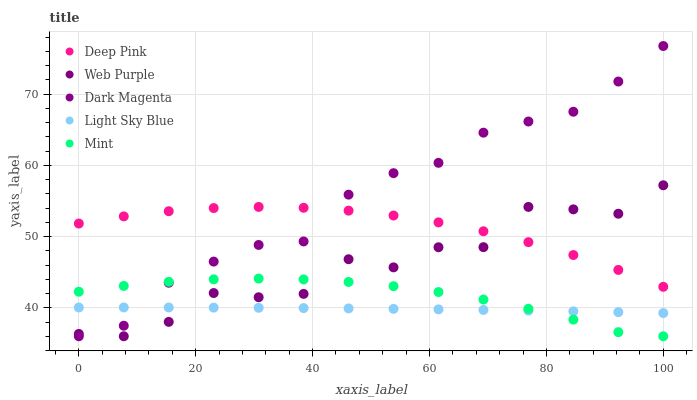Does Light Sky Blue have the minimum area under the curve?
Answer yes or no. Yes. Does Dark Magenta have the maximum area under the curve?
Answer yes or no. Yes. Does Deep Pink have the minimum area under the curve?
Answer yes or no. No. Does Deep Pink have the maximum area under the curve?
Answer yes or no. No. Is Light Sky Blue the smoothest?
Answer yes or no. Yes. Is Web Purple the roughest?
Answer yes or no. Yes. Is Deep Pink the smoothest?
Answer yes or no. No. Is Deep Pink the roughest?
Answer yes or no. No. Does Web Purple have the lowest value?
Answer yes or no. Yes. Does Deep Pink have the lowest value?
Answer yes or no. No. Does Dark Magenta have the highest value?
Answer yes or no. Yes. Does Deep Pink have the highest value?
Answer yes or no. No. Is Light Sky Blue less than Deep Pink?
Answer yes or no. Yes. Is Deep Pink greater than Mint?
Answer yes or no. Yes. Does Web Purple intersect Deep Pink?
Answer yes or no. Yes. Is Web Purple less than Deep Pink?
Answer yes or no. No. Is Web Purple greater than Deep Pink?
Answer yes or no. No. Does Light Sky Blue intersect Deep Pink?
Answer yes or no. No. 